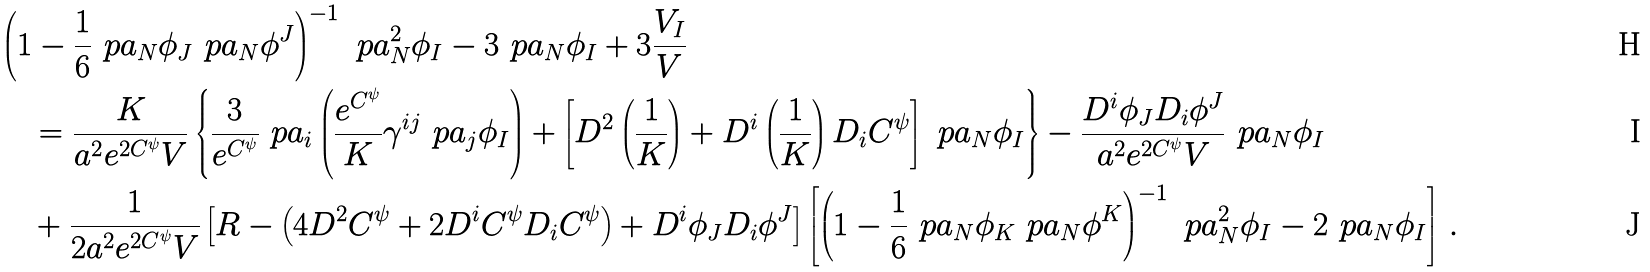<formula> <loc_0><loc_0><loc_500><loc_500>& \left ( 1 - \frac { 1 } { 6 } \ p a _ { N } \phi _ { J } \ p a _ { N } \phi ^ { J } \right ) ^ { - 1 } \ p a _ { N } ^ { 2 } \phi _ { I } - 3 \ p a _ { N } \phi _ { I } + 3 \frac { V _ { I } } { V } \\ & \quad = \frac { K } { a ^ { 2 } e ^ { 2 C ^ { \psi } } V } \left \{ \frac { 3 } { e ^ { C ^ { \psi } } } \ p a _ { i } \left ( \frac { e ^ { C ^ { \psi } } } { K } \gamma ^ { i j } \ p a _ { j } \phi _ { I } \right ) + \left [ D ^ { 2 } \left ( \frac { 1 } { K } \right ) + D ^ { i } \left ( \frac { 1 } { K } \right ) D _ { i } C ^ { \psi } \right ] \ p a _ { N } \phi _ { I } \right \} - \frac { D ^ { i } \phi _ { J } D _ { i } \phi ^ { J } } { a ^ { 2 } e ^ { 2 C ^ { \psi } } V } \ p a _ { N } \phi _ { I } \\ & \quad + \frac { 1 } { 2 a ^ { 2 } e ^ { 2 C ^ { \psi } } V } \left [ R - \left ( 4 D ^ { 2 } C ^ { \psi } + 2 D ^ { i } C ^ { \psi } D _ { i } C ^ { \psi } \right ) + D ^ { i } \phi _ { J } D _ { i } \phi ^ { J } \right ] \left [ \left ( 1 - \frac { 1 } { 6 } \ p a _ { N } \phi _ { K } \ p a _ { N } \phi ^ { K } \right ) ^ { - 1 } \ p a _ { N } ^ { 2 } \phi _ { I } - 2 \ p a _ { N } \phi _ { I } \right ] \, .</formula> 